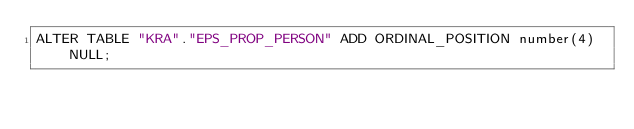<code> <loc_0><loc_0><loc_500><loc_500><_SQL_>ALTER TABLE "KRA"."EPS_PROP_PERSON" ADD ORDINAL_POSITION number(4) NULL;

</code> 